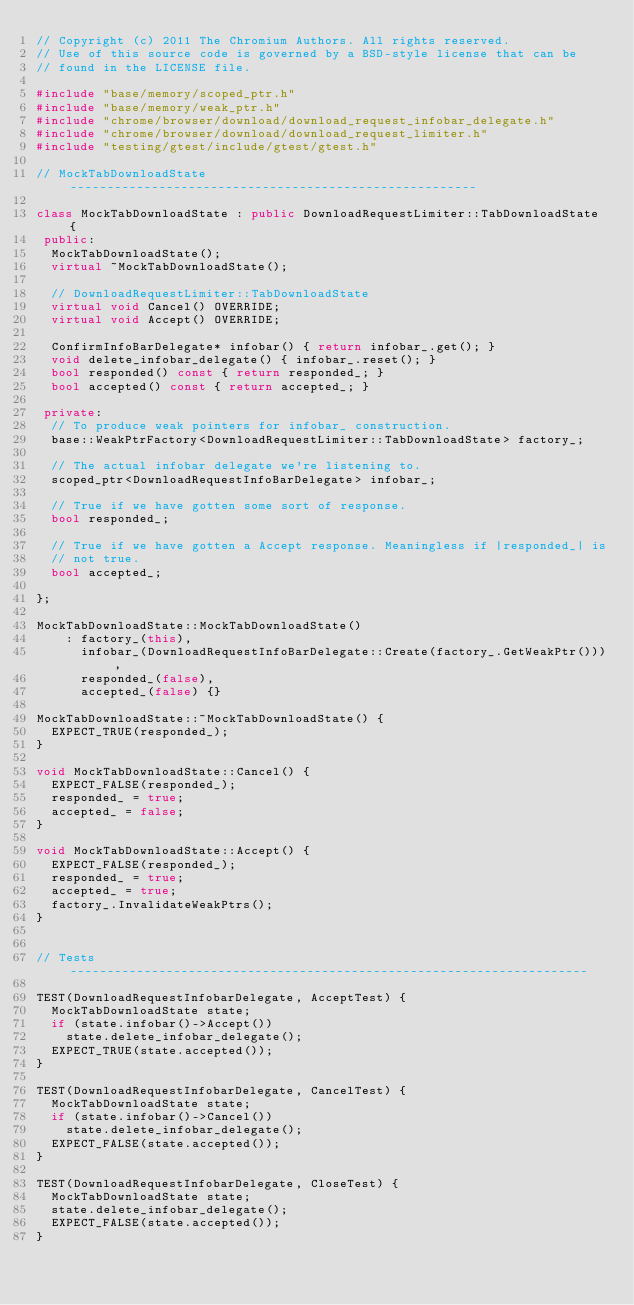Convert code to text. <code><loc_0><loc_0><loc_500><loc_500><_C++_>// Copyright (c) 2011 The Chromium Authors. All rights reserved.
// Use of this source code is governed by a BSD-style license that can be
// found in the LICENSE file.

#include "base/memory/scoped_ptr.h"
#include "base/memory/weak_ptr.h"
#include "chrome/browser/download/download_request_infobar_delegate.h"
#include "chrome/browser/download/download_request_limiter.h"
#include "testing/gtest/include/gtest/gtest.h"

// MockTabDownloadState -------------------------------------------------------

class MockTabDownloadState : public DownloadRequestLimiter::TabDownloadState {
 public:
  MockTabDownloadState();
  virtual ~MockTabDownloadState();

  // DownloadRequestLimiter::TabDownloadState
  virtual void Cancel() OVERRIDE;
  virtual void Accept() OVERRIDE;

  ConfirmInfoBarDelegate* infobar() { return infobar_.get(); }
  void delete_infobar_delegate() { infobar_.reset(); }
  bool responded() const { return responded_; }
  bool accepted() const { return accepted_; }

 private:
  // To produce weak pointers for infobar_ construction.
  base::WeakPtrFactory<DownloadRequestLimiter::TabDownloadState> factory_;

  // The actual infobar delegate we're listening to.
  scoped_ptr<DownloadRequestInfoBarDelegate> infobar_;

  // True if we have gotten some sort of response.
  bool responded_;

  // True if we have gotten a Accept response. Meaningless if |responded_| is
  // not true.
  bool accepted_;

};

MockTabDownloadState::MockTabDownloadState()
    : factory_(this),
      infobar_(DownloadRequestInfoBarDelegate::Create(factory_.GetWeakPtr())),
      responded_(false),
      accepted_(false) {}

MockTabDownloadState::~MockTabDownloadState() {
  EXPECT_TRUE(responded_);
}

void MockTabDownloadState::Cancel() {
  EXPECT_FALSE(responded_);
  responded_ = true;
  accepted_ = false;
}

void MockTabDownloadState::Accept() {
  EXPECT_FALSE(responded_);
  responded_ = true;
  accepted_ = true;
  factory_.InvalidateWeakPtrs();
}


// Tests ----------------------------------------------------------------------

TEST(DownloadRequestInfobarDelegate, AcceptTest) {
  MockTabDownloadState state;
  if (state.infobar()->Accept())
    state.delete_infobar_delegate();
  EXPECT_TRUE(state.accepted());
}

TEST(DownloadRequestInfobarDelegate, CancelTest) {
  MockTabDownloadState state;
  if (state.infobar()->Cancel())
    state.delete_infobar_delegate();
  EXPECT_FALSE(state.accepted());
}

TEST(DownloadRequestInfobarDelegate, CloseTest) {
  MockTabDownloadState state;
  state.delete_infobar_delegate();
  EXPECT_FALSE(state.accepted());
}
</code> 